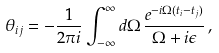<formula> <loc_0><loc_0><loc_500><loc_500>\theta _ { i j } = - \frac { 1 } { 2 \pi i } \int _ { - \infty } ^ { \infty } d \Omega \, \frac { e ^ { - i \Omega ( t _ { i } - t _ { j } ) } } { \Omega + i \epsilon } \, ,</formula> 